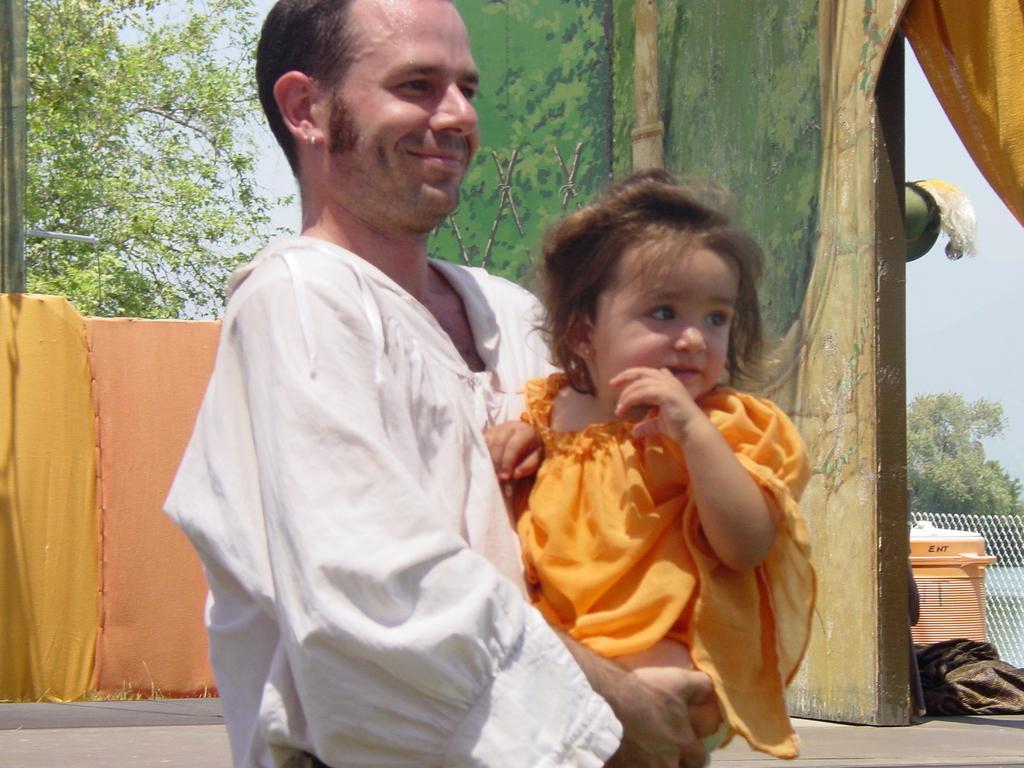How would you summarize this image in a sentence or two? In the picture we can see a man standing and holding a baby, a man is with white dress and baby is in yellow dress and behind them, we can see a wooden wall with some tree paintings on it and near it, we can see some things are placed and behind it we can see a fencing wall and far away from it we can see trees and the sky. 